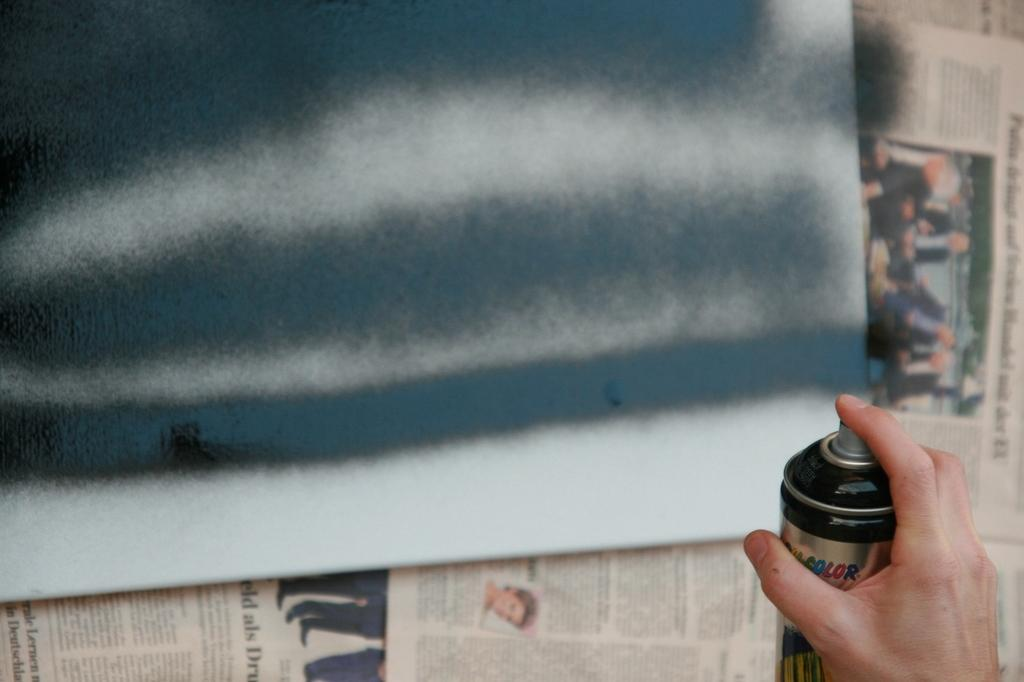What is the person in the image doing? The person is spraying color in the image. What color is being sprayed by the person? The color being sprayed is black. What is the person spraying color on? The person is spraying color on a board. What else can be seen near the board in the image? There are newspapers beside the board. What type of stocking is the person wearing while spraying color in the image? There is no information about the person's clothing, including stockings, in the image. How does the person's anger affect the color being sprayed in the image? There is no indication of the person's emotions, such as anger, in the image. 